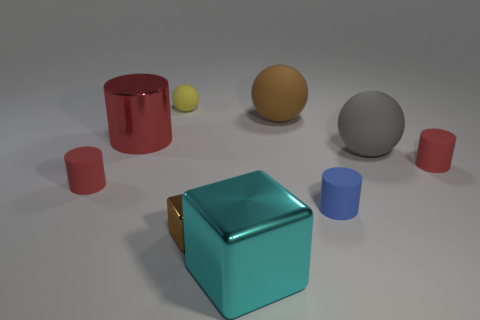What can you infer about the materials of the objects? The objects in the image appear to be made of different materials based on their surfaces and reflections. The teal cube and the red cylinder have shiny, reflective surfaces that suggest they could be metallic. The gray and yellow spheres have a matte finish, hinting at a possible plastic or ceramic composition. Meanwhile, the smaller cylinders also have a less reflective surface, similar to the spheres, indicating they might not be metal. 